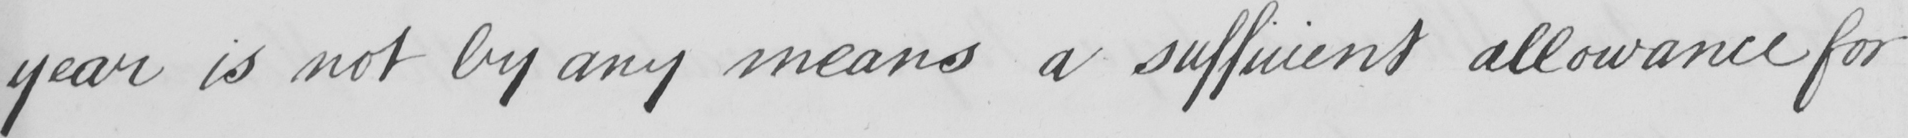Please transcribe the handwritten text in this image. year is not by any means a sufficient allowance for 